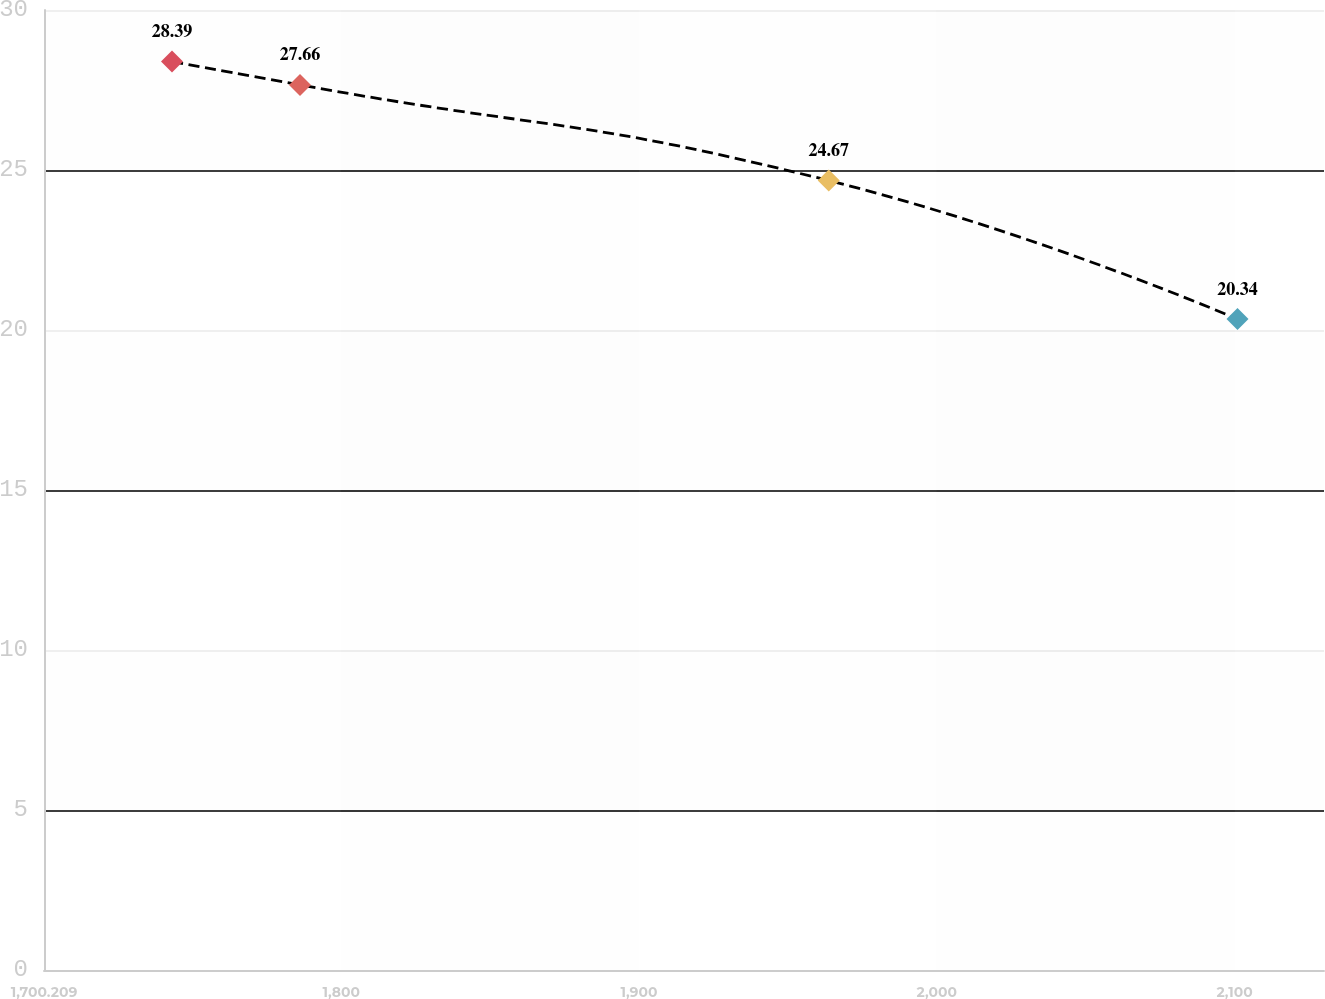Convert chart to OTSL. <chart><loc_0><loc_0><loc_500><loc_500><line_chart><ecel><fcel>Unnamed: 1<nl><fcel>1743.19<fcel>28.39<nl><fcel>1786.17<fcel>27.66<nl><fcel>1963.72<fcel>24.67<nl><fcel>2100.97<fcel>20.34<nl><fcel>2173<fcel>22.41<nl></chart> 